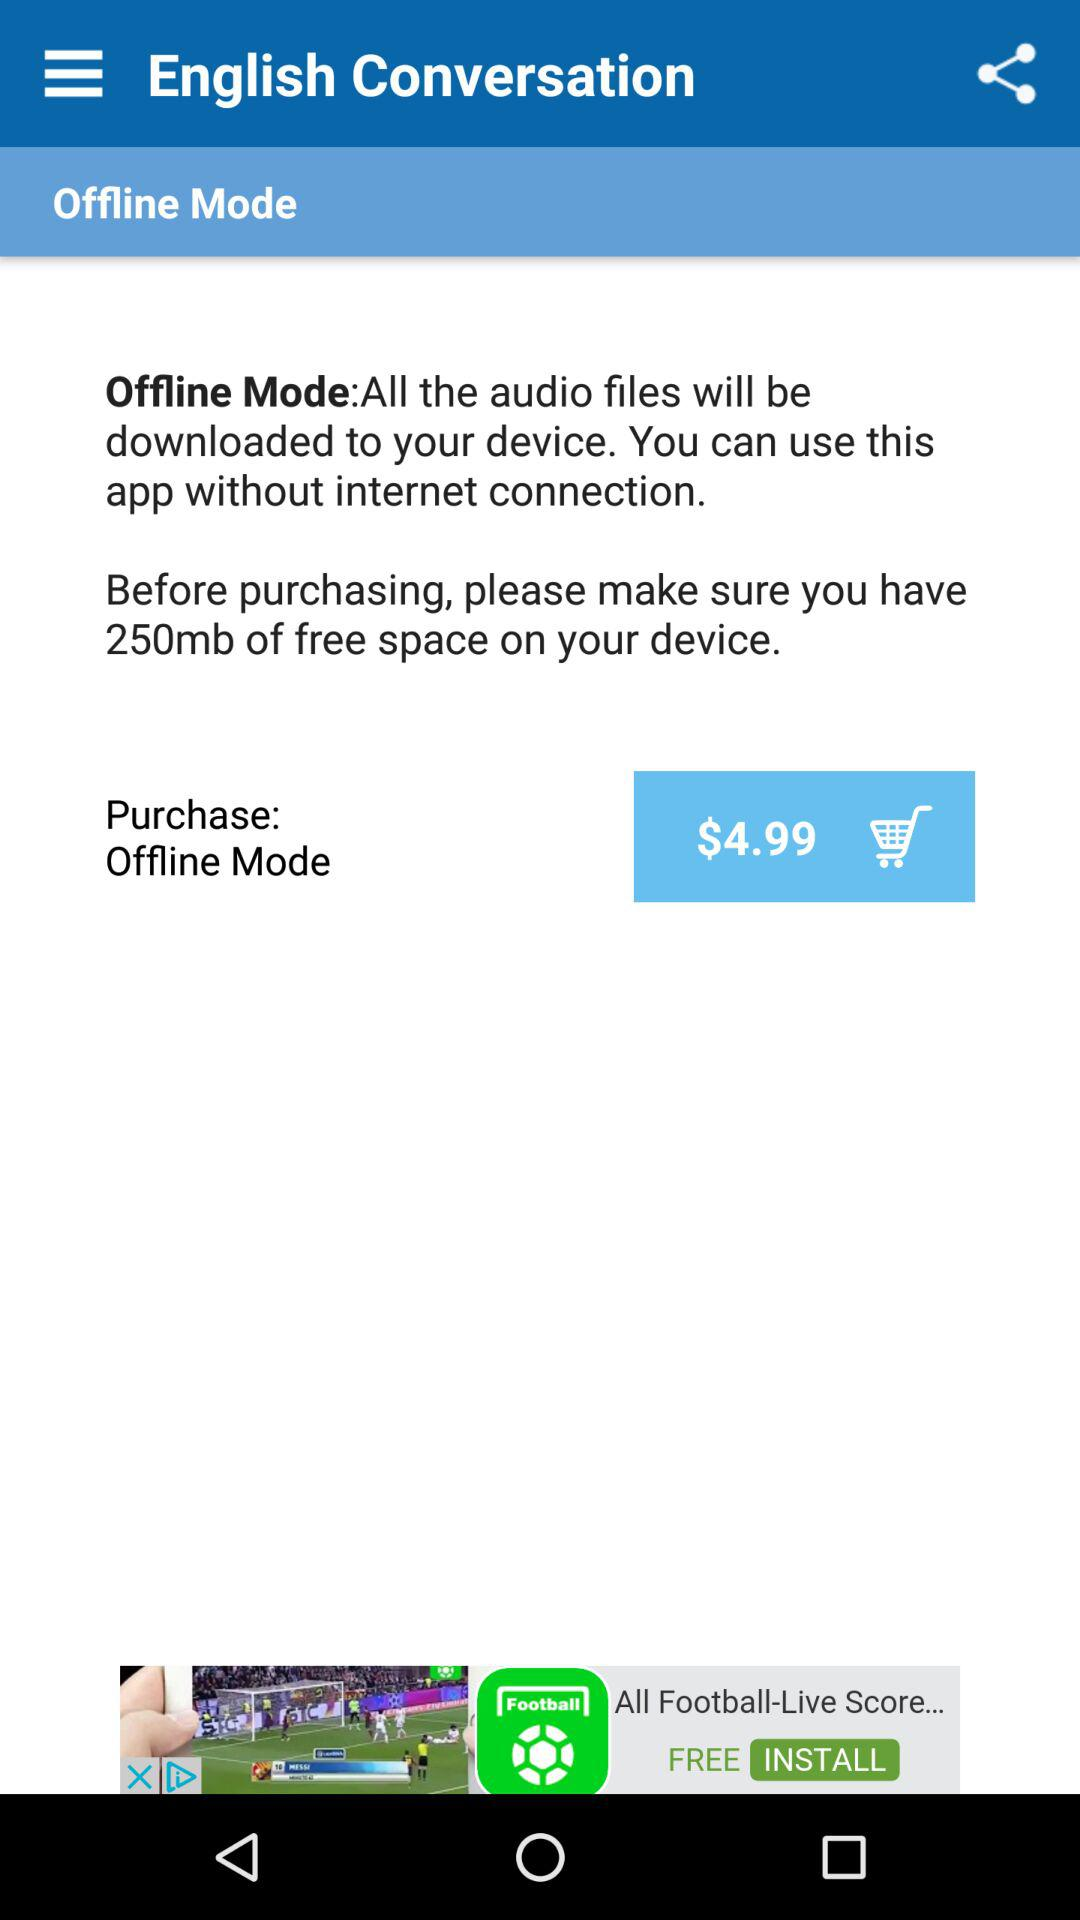What is the purchase mode? The purchase mode is offline. 